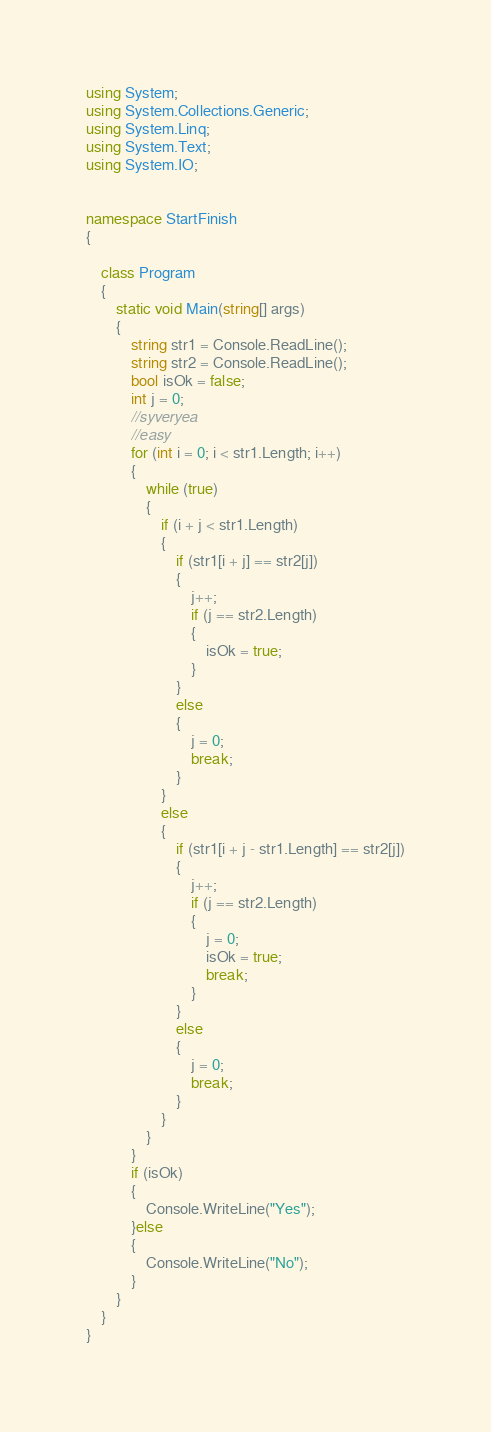Convert code to text. <code><loc_0><loc_0><loc_500><loc_500><_C#_>
using System;
using System.Collections.Generic;
using System.Linq;
using System.Text;
using System.IO;


namespace StartFinish
{

    class Program
    {
        static void Main(string[] args)
        {
            string str1 = Console.ReadLine();
            string str2 = Console.ReadLine();
            bool isOk = false;
            int j = 0;
            //syveryea
            //easy
            for (int i = 0; i < str1.Length; i++)
            {
                while (true)
                {
                    if (i + j < str1.Length)
                    {
                        if (str1[i + j] == str2[j])
                        {
                            j++;
                            if (j == str2.Length)
                            {
                                isOk = true;
                            }
                        }
                        else
                        {
                            j = 0;
                            break;
                        }
                    }
                    else
                    {
                        if (str1[i + j - str1.Length] == str2[j])
                        {
                            j++;
                            if (j == str2.Length)
                            {
                                j = 0;
                                isOk = true;
                                break;
                            }
                        }
                        else
                        {
                            j = 0;
                            break;
                        }
                    }
                }
            }
            if (isOk)
            {
                Console.WriteLine("Yes");
            }else
            {
                Console.WriteLine("No");
            }
        }
    }
}</code> 